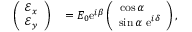Convert formula to latex. <formula><loc_0><loc_0><loc_500><loc_500>\begin{array} { r l } { \left ( \begin{array} { c } { \mathcal { E } _ { x } } \\ { \mathcal { E } _ { y } } \end{array} \right ) } & = E _ { 0 } e ^ { i \beta } \left ( \begin{array} { c } { \cos \alpha \quad } \\ { \sin \alpha \ e ^ { i \delta } } \end{array} \right ) , } \end{array}</formula> 